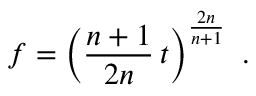Convert formula to latex. <formula><loc_0><loc_0><loc_500><loc_500>f = \left ( \frac { n + 1 } { 2 n } \, t \right ) ^ { \frac { 2 n } { n + 1 } } \ .</formula> 